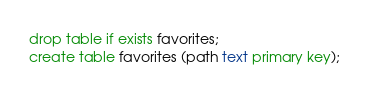<code> <loc_0><loc_0><loc_500><loc_500><_SQL_>drop table if exists favorites;
create table favorites (path text primary key);

</code> 